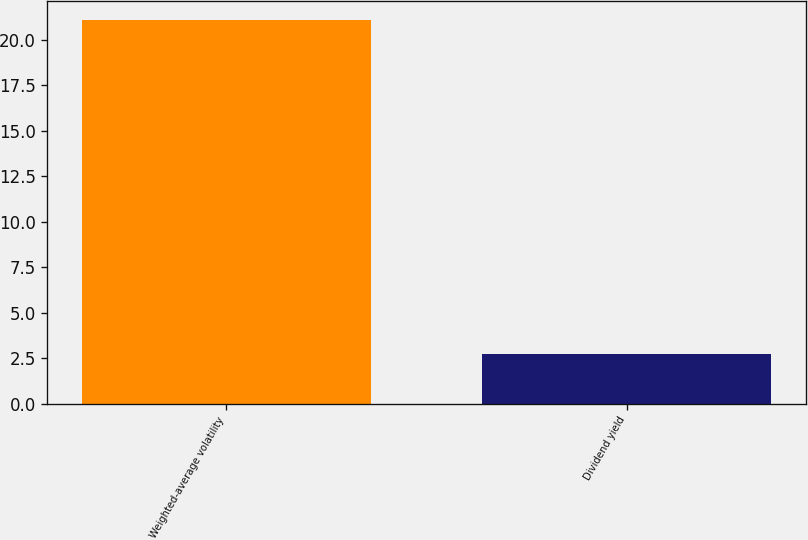<chart> <loc_0><loc_0><loc_500><loc_500><bar_chart><fcel>Weighted-average volatility<fcel>Dividend yield<nl><fcel>21.1<fcel>2.72<nl></chart> 